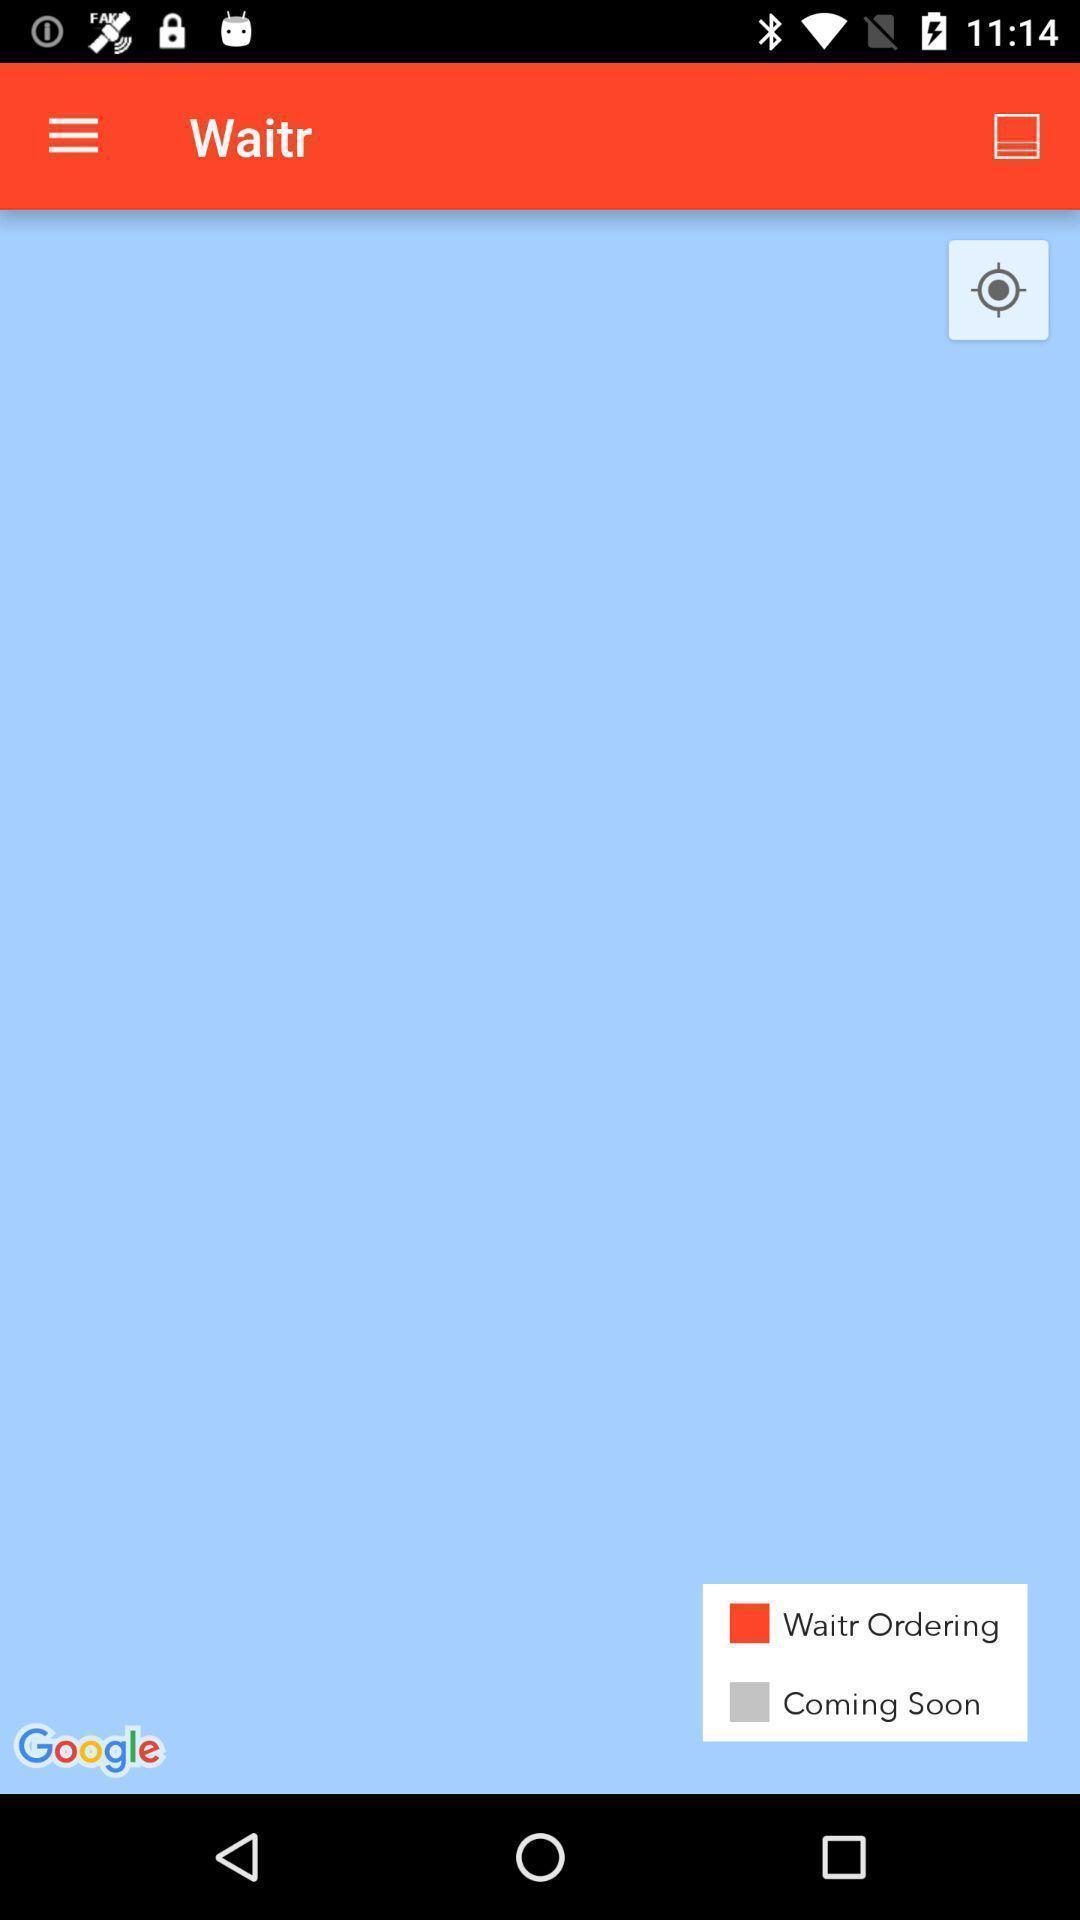Provide a textual representation of this image. Screen shows multiple options in a food application. 